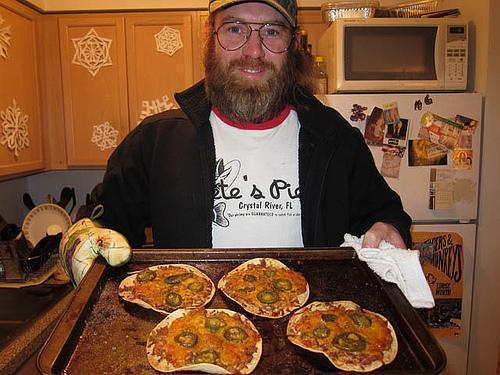How can you tell that this guy likes his food a little spicy?
Indicate the correct choice and explain in the format: 'Answer: answer
Rationale: rationale.'
Options: Salsa, jalapenos, tabasco, hot sauce. Answer: jalapenos.
Rationale: The man has prepared food that includes a green pepper based on the size and shape. this food is known to be associated with spiciness. 